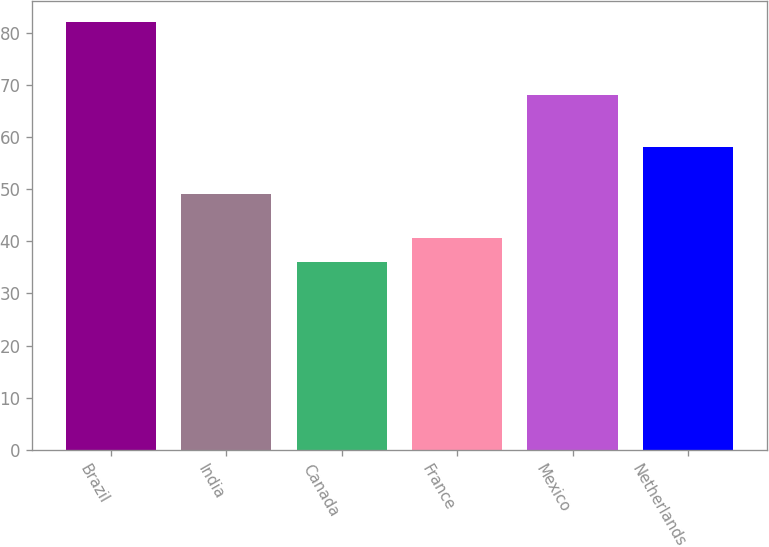<chart> <loc_0><loc_0><loc_500><loc_500><bar_chart><fcel>Brazil<fcel>India<fcel>Canada<fcel>France<fcel>Mexico<fcel>Netherlands<nl><fcel>82<fcel>49<fcel>36<fcel>40.6<fcel>68<fcel>58<nl></chart> 